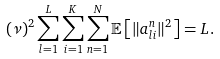Convert formula to latex. <formula><loc_0><loc_0><loc_500><loc_500>( \nu ) ^ { 2 } \sum _ { l = 1 } ^ { L } \sum _ { i = 1 } ^ { K } \sum _ { n = 1 } ^ { N } \mathbb { E } \left [ \| { a } _ { l i } ^ { n } \| ^ { 2 } \right ] & = L .</formula> 